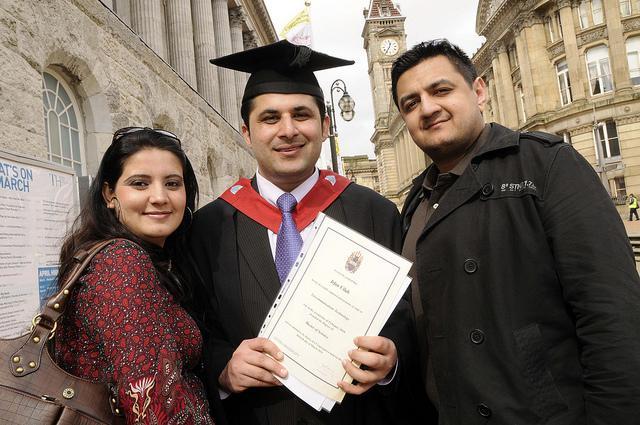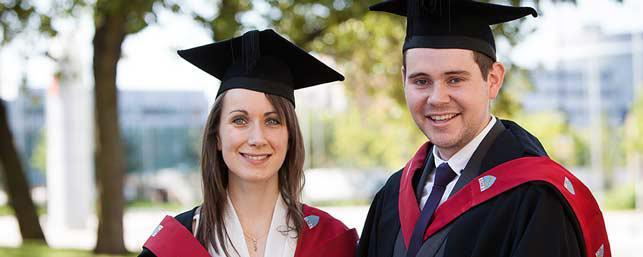The first image is the image on the left, the second image is the image on the right. Analyze the images presented: Is the assertion "An image shows three female graduates posing together wearing black grad caps." valid? Answer yes or no. No. The first image is the image on the left, the second image is the image on the right. Assess this claim about the two images: "Each image shows at least three graduates standing together wearing black gowns with red trim and black mortarboards". Correct or not? Answer yes or no. No. 